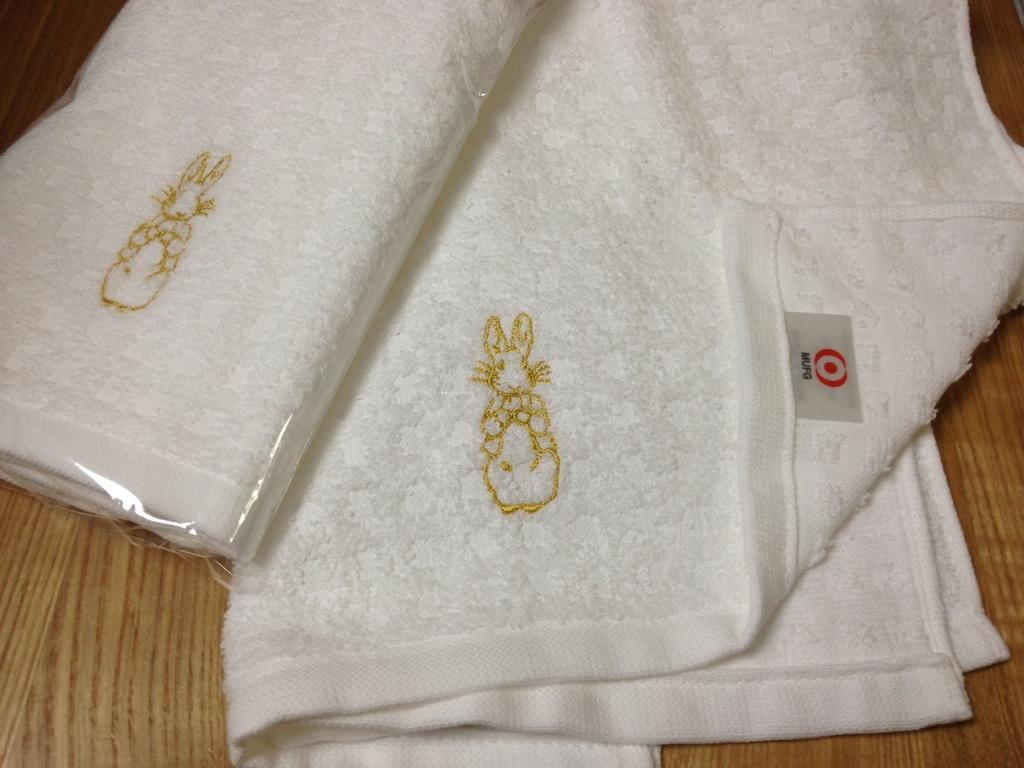What color are the clothes in the image? The clothes in the image are white. What type of design or pattern is present on the clothes? The clothes have embroidery work on them. Are there any men wearing vests in the image? There is no information about men or vests in the provided facts, so we cannot answer this question based on the image. 